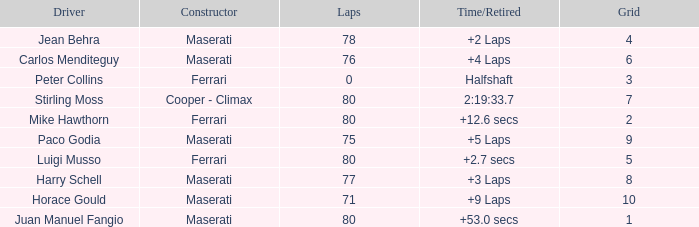What were the lowest laps of Luigi Musso driving a Ferrari with a Grid larger than 2? 80.0. 